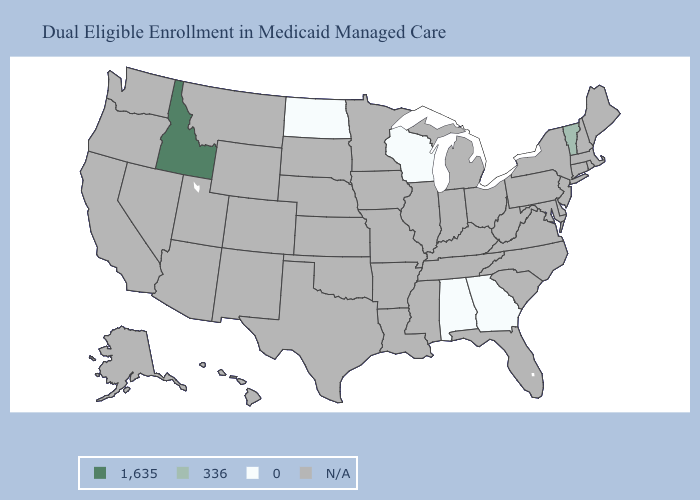Does the first symbol in the legend represent the smallest category?
Write a very short answer. No. What is the value of New York?
Short answer required. N/A. What is the value of Kentucky?
Be succinct. N/A. Does Idaho have the lowest value in the USA?
Give a very brief answer. No. What is the lowest value in the USA?
Answer briefly. 0. Name the states that have a value in the range N/A?
Concise answer only. Alaska, Arizona, Arkansas, California, Colorado, Connecticut, Delaware, Florida, Hawaii, Illinois, Indiana, Iowa, Kansas, Kentucky, Louisiana, Maine, Maryland, Massachusetts, Michigan, Minnesota, Mississippi, Missouri, Montana, Nebraska, Nevada, New Hampshire, New Jersey, New Mexico, New York, North Carolina, Ohio, Oklahoma, Oregon, Pennsylvania, Rhode Island, South Carolina, South Dakota, Tennessee, Texas, Utah, Virginia, Washington, West Virginia, Wyoming. Name the states that have a value in the range 0?
Be succinct. Alabama, Georgia, North Dakota, Wisconsin. Name the states that have a value in the range 336?
Answer briefly. Vermont. What is the lowest value in states that border South Dakota?
Answer briefly. 0. What is the value of Kansas?
Answer briefly. N/A. How many symbols are there in the legend?
Keep it brief. 4. 